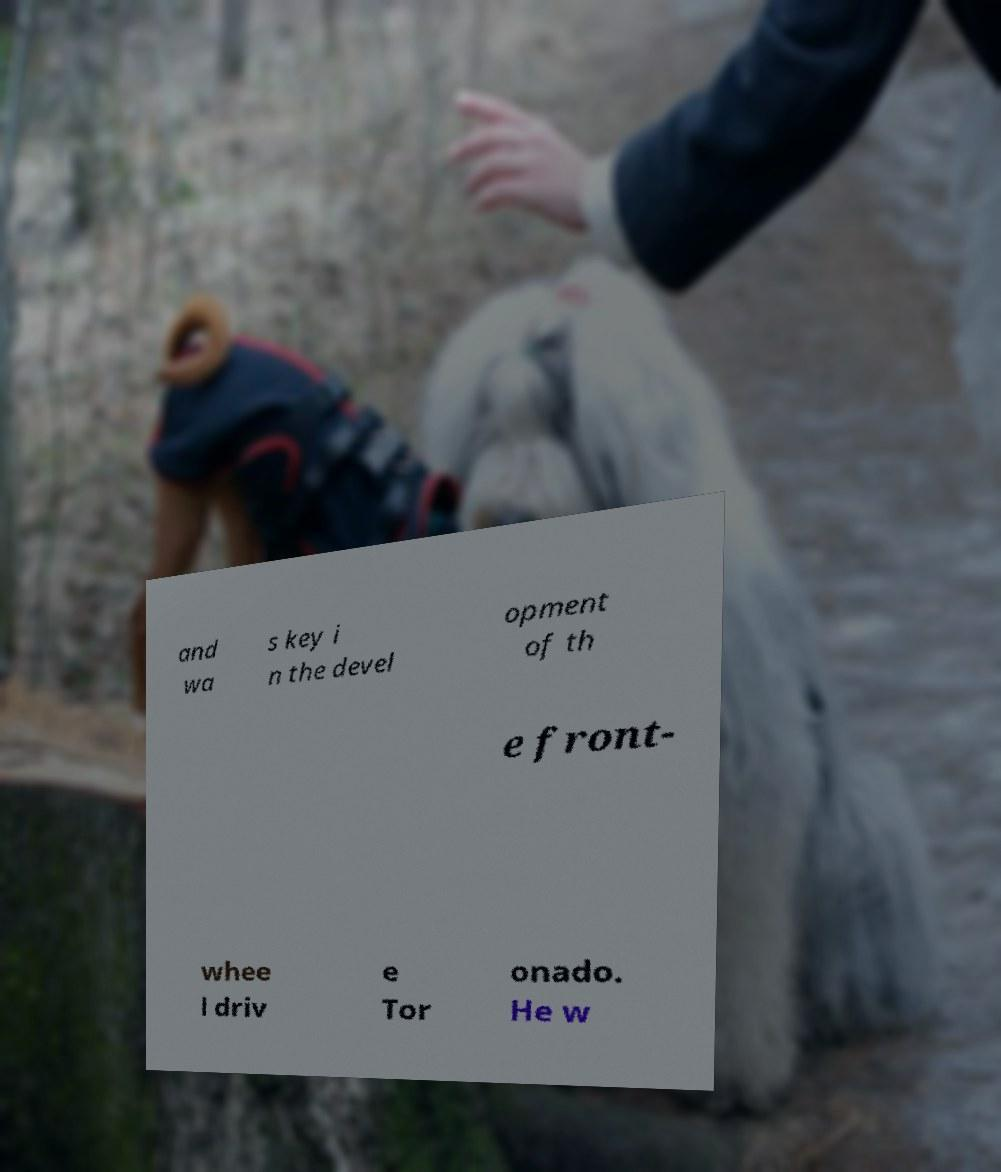Can you accurately transcribe the text from the provided image for me? and wa s key i n the devel opment of th e front- whee l driv e Tor onado. He w 